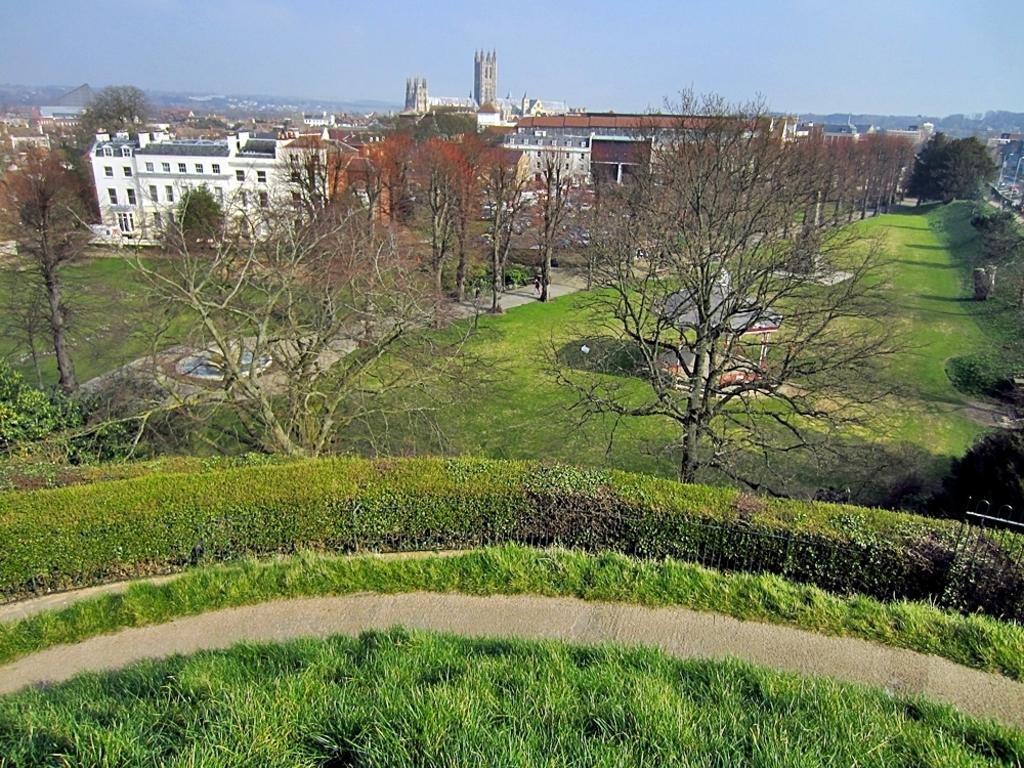What type of vegetation can be seen in the image? There are plants and trees in the image. What color are the plants and trees? The plants and trees are green. What can be seen in the background of the image? There are buildings in the background of the image. What colors are the buildings? The buildings are white and cream-colored. What is the color of the sky in the image? The sky is blue. Can you hear the plants and trees laughing in the image? There is no sound or laughter present in the image; it is a still image of plants, trees, buildings, and a blue sky. 